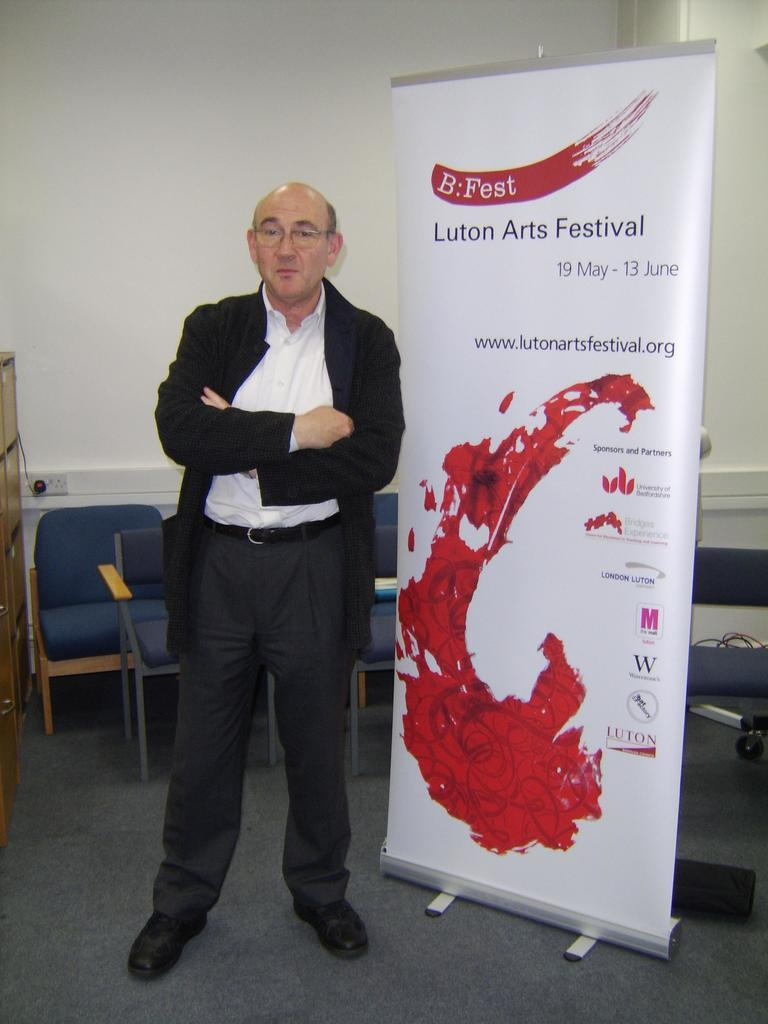What is the main subject of the image? There is a man standing in the image. Can you describe the man's appearance? The man is wearing glasses (specs). What can be seen in the background of the image? There are chairs and a banner in the background of the image. How many icicles are hanging from the man's glasses in the image? There are no icicles present in the image, as it is not a cold environment where icicles would form. 